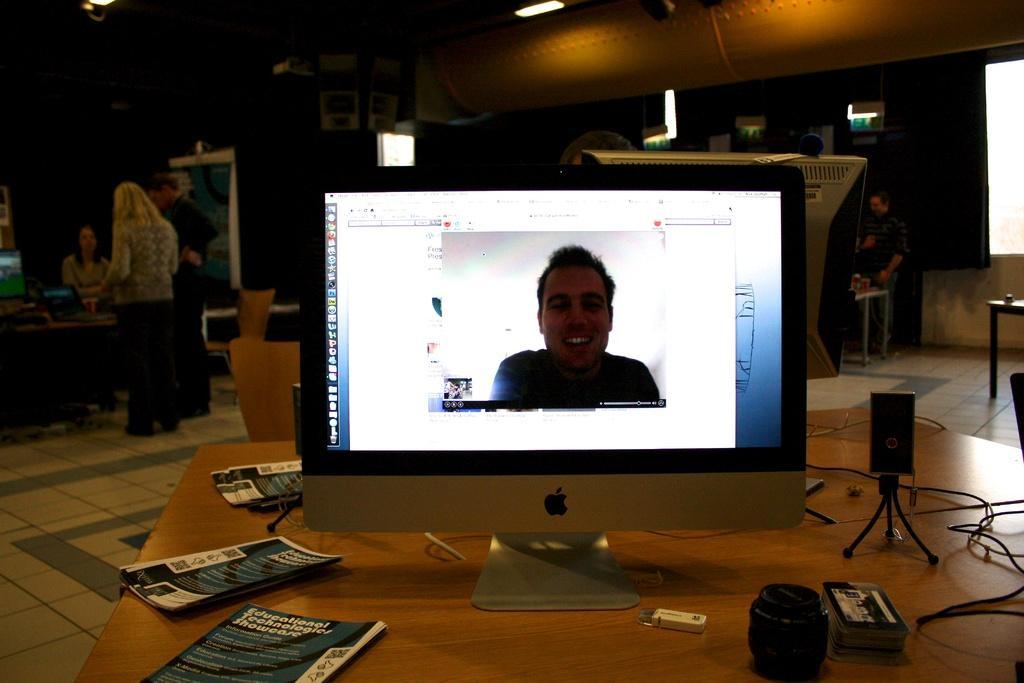In one or two sentences, can you explain what this image depicts? In this picture we can see a computer, posters, bottle, box and a few devices on the table. We can see a woman sitting on the chair at the back. There is a poster. We can see a few people. We can see some lights on top. 